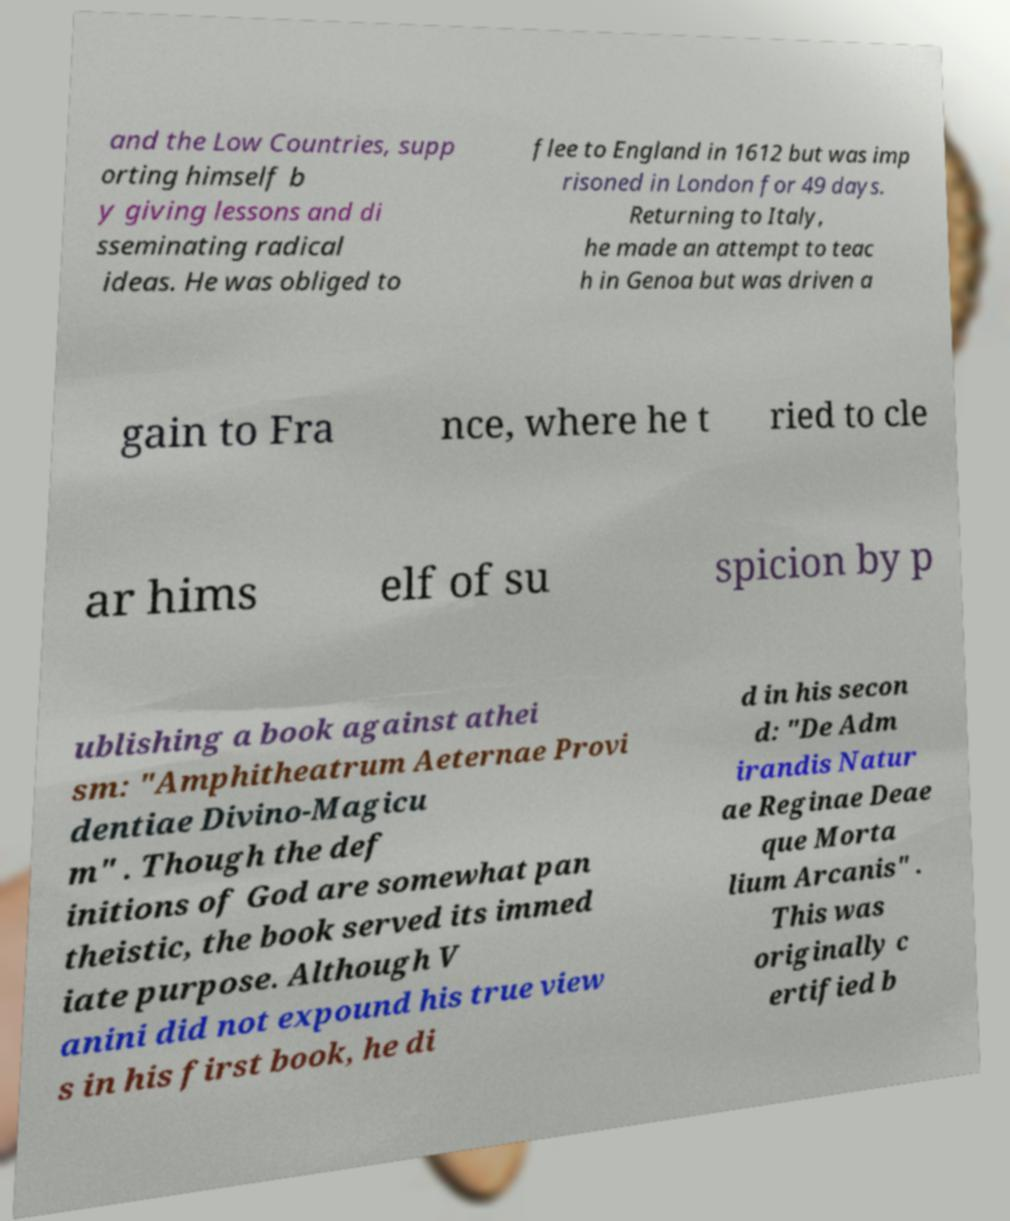For documentation purposes, I need the text within this image transcribed. Could you provide that? and the Low Countries, supp orting himself b y giving lessons and di sseminating radical ideas. He was obliged to flee to England in 1612 but was imp risoned in London for 49 days. Returning to Italy, he made an attempt to teac h in Genoa but was driven a gain to Fra nce, where he t ried to cle ar hims elf of su spicion by p ublishing a book against athei sm: "Amphitheatrum Aeternae Provi dentiae Divino-Magicu m" . Though the def initions of God are somewhat pan theistic, the book served its immed iate purpose. Although V anini did not expound his true view s in his first book, he di d in his secon d: "De Adm irandis Natur ae Reginae Deae que Morta lium Arcanis" . This was originally c ertified b 